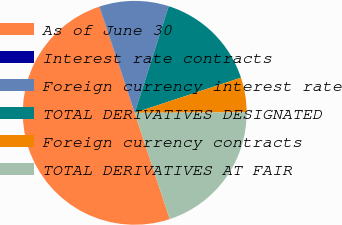Convert chart. <chart><loc_0><loc_0><loc_500><loc_500><pie_chart><fcel>As of June 30<fcel>Interest rate contracts<fcel>Foreign currency interest rate<fcel>TOTAL DERIVATIVES DESIGNATED<fcel>Foreign currency contracts<fcel>TOTAL DERIVATIVES AT FAIR<nl><fcel>49.95%<fcel>0.02%<fcel>10.01%<fcel>15.0%<fcel>5.02%<fcel>20.0%<nl></chart> 